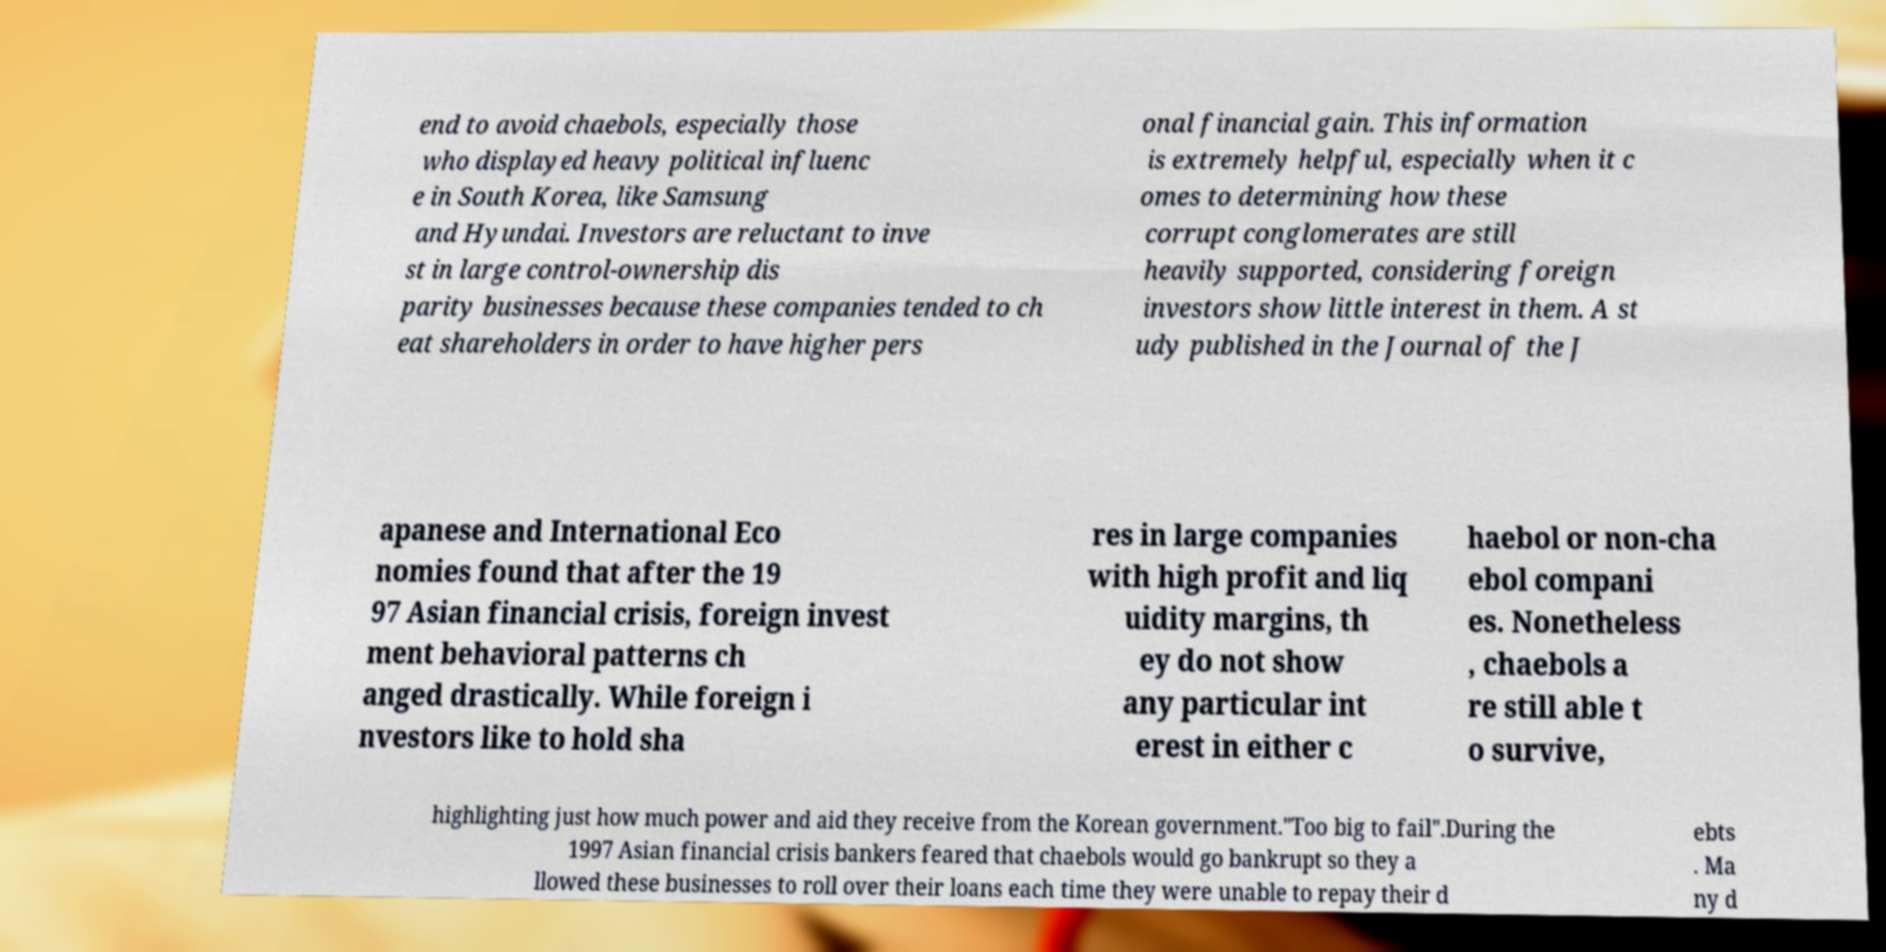Please read and relay the text visible in this image. What does it say? end to avoid chaebols, especially those who displayed heavy political influenc e in South Korea, like Samsung and Hyundai. Investors are reluctant to inve st in large control-ownership dis parity businesses because these companies tended to ch eat shareholders in order to have higher pers onal financial gain. This information is extremely helpful, especially when it c omes to determining how these corrupt conglomerates are still heavily supported, considering foreign investors show little interest in them. A st udy published in the Journal of the J apanese and International Eco nomies found that after the 19 97 Asian financial crisis, foreign invest ment behavioral patterns ch anged drastically. While foreign i nvestors like to hold sha res in large companies with high profit and liq uidity margins, th ey do not show any particular int erest in either c haebol or non-cha ebol compani es. Nonetheless , chaebols a re still able t o survive, highlighting just how much power and aid they receive from the Korean government."Too big to fail".During the 1997 Asian financial crisis bankers feared that chaebols would go bankrupt so they a llowed these businesses to roll over their loans each time they were unable to repay their d ebts . Ma ny d 